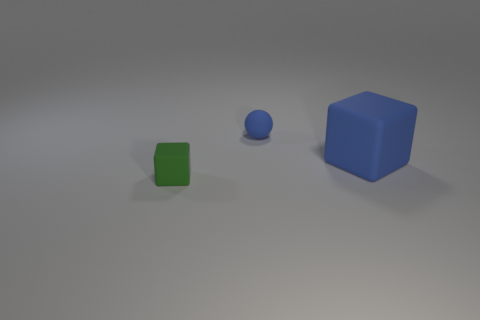What number of tiny things are either blue rubber objects or red things?
Provide a short and direct response. 1. What is the material of the tiny green thing that is the same shape as the big object?
Your answer should be very brief. Rubber. Are there any other things that are made of the same material as the large thing?
Keep it short and to the point. Yes. What is the color of the big rubber block?
Keep it short and to the point. Blue. Does the small block have the same color as the big block?
Your answer should be compact. No. What number of large blue blocks are to the left of the matte sphere that is left of the large matte cube?
Ensure brevity in your answer.  0. There is a thing that is on the right side of the green matte block and in front of the matte ball; what size is it?
Keep it short and to the point. Large. What is the material of the object to the left of the matte sphere?
Make the answer very short. Rubber. Are there any other big things that have the same shape as the green rubber object?
Ensure brevity in your answer.  Yes. What number of other green things are the same shape as the big matte thing?
Keep it short and to the point. 1. 